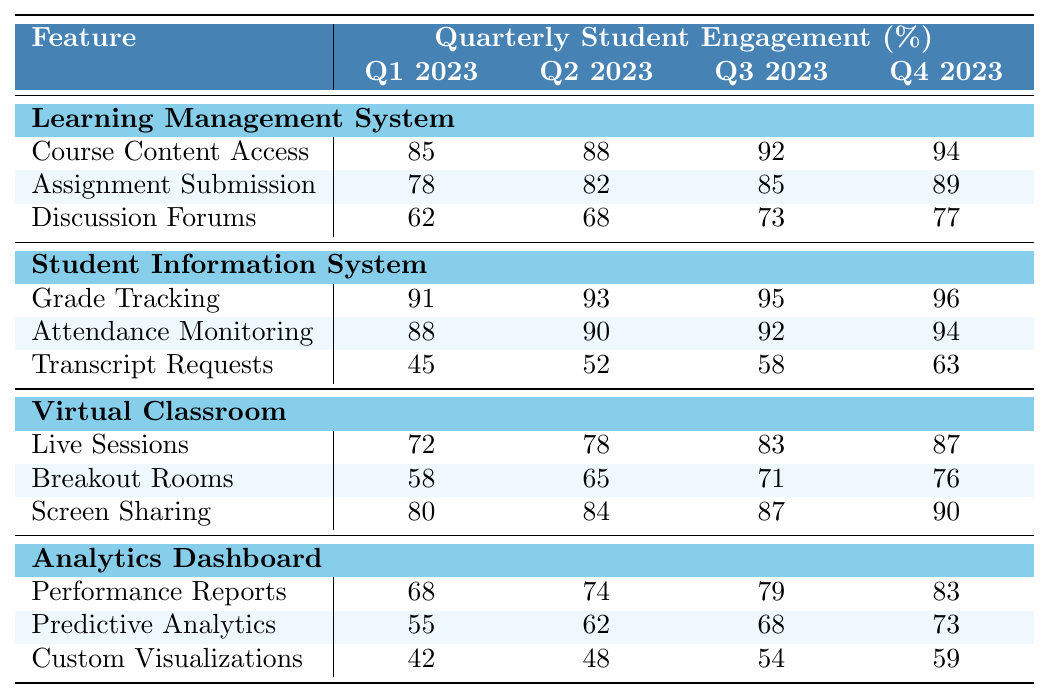What was the engagement percentage for Course Content Access in Q3 2023? From the table, we look under the "Learning Management System" section at the row for "Course Content Access" and find the value for Q3 2023, which is 92%.
Answer: 92% Which feature had the highest engagement percentage in Q1 2023? In Q1 2023, we examine all features; "Grade Tracking" under "Student Information System" has the highest engagement at 91%.
Answer: 91% What is the average engagement percentage for Discussion Forums across all quarters? We take the values for Discussion Forums: 62, 68, 73, and 77. Adding them gives (62 + 68 + 73 + 77) = 280, and dividing by 4 results in an average of 70.
Answer: 70 Did the engagement percentage for Screen Sharing increase every quarter? Analyzing the data, the engagement percentages for Screen Sharing are 80, 84, 87, and 90, which all show an increase from one quarter to the next. Thus, it did increase every quarter.
Answer: Yes What is the difference in engagement percentage for Transcript Requests between Q1 and Q4 2023? The values for Transcript Requests in Q1 and Q4 are 45 and 63, respectively. The difference is calculated as 63 - 45 = 18.
Answer: 18 What feature experienced the highest overall engagement improvement from Q1 to Q4 2023? To find this, we calculate the engagement change for each feature from Q1 to Q4. The largest improvement is seen in "Grade Tracking," which increased from 91 to 96, a total of 5 points.
Answer: Grade Tracking What was the total engagement percentage for all subfeatures under the Virtual Classroom in Q2 2023? We look at the Virtual Classroom subfeatures: Live Sessions (78), Breakout Rooms (65), and Screen Sharing (84). Summing these gives (78 + 65 + 84) = 227.
Answer: 227 Did the engagement percentage for Predictive Analytics surpass 60% in any quarter? Examining the values for Predictive Analytics, we see they are 55, 62, 68, and 73. It surpassed 60% in Q2 (62), Q3 (68), and Q4 (73).
Answer: Yes What was the increase in engagement percentage for Assignment Submission from Q1 to Q3 2023? For Assignment Submission, the values for Q1 and Q3 are 78 and 85, respectively. The increase is 85 - 78 = 7.
Answer: 7 What was the lowest engagement percentage recorded across all features in Q4 2023? Investigating the values in Q4 2023, "Transcript Requests" at 63 is the lowest figure among all features listed.
Answer: 63 